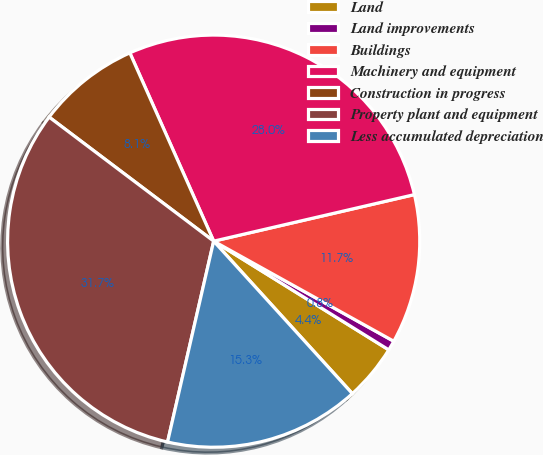<chart> <loc_0><loc_0><loc_500><loc_500><pie_chart><fcel>Land<fcel>Land improvements<fcel>Buildings<fcel>Machinery and equipment<fcel>Construction in progress<fcel>Property plant and equipment<fcel>Less accumulated depreciation<nl><fcel>4.41%<fcel>0.77%<fcel>11.7%<fcel>28.04%<fcel>8.05%<fcel>31.69%<fcel>15.34%<nl></chart> 